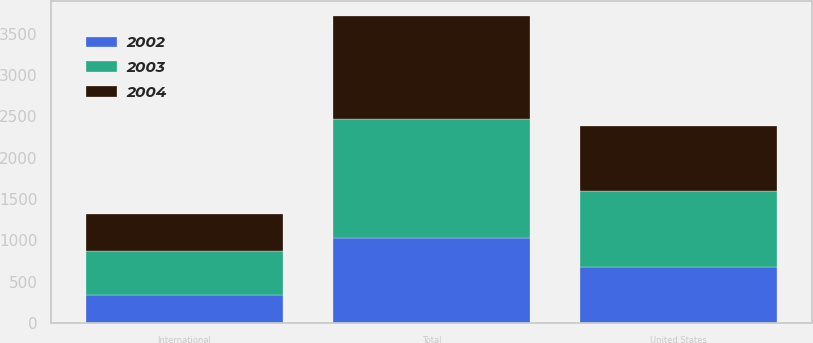Convert chart to OTSL. <chart><loc_0><loc_0><loc_500><loc_500><stacked_bar_chart><ecel><fcel>United States<fcel>International<fcel>Total<nl><fcel>2003<fcel>911.2<fcel>527.1<fcel>1438.3<nl><fcel>2004<fcel>795.3<fcel>451.3<fcel>1246.6<nl><fcel>2002<fcel>680.8<fcel>342.5<fcel>1023.3<nl></chart> 